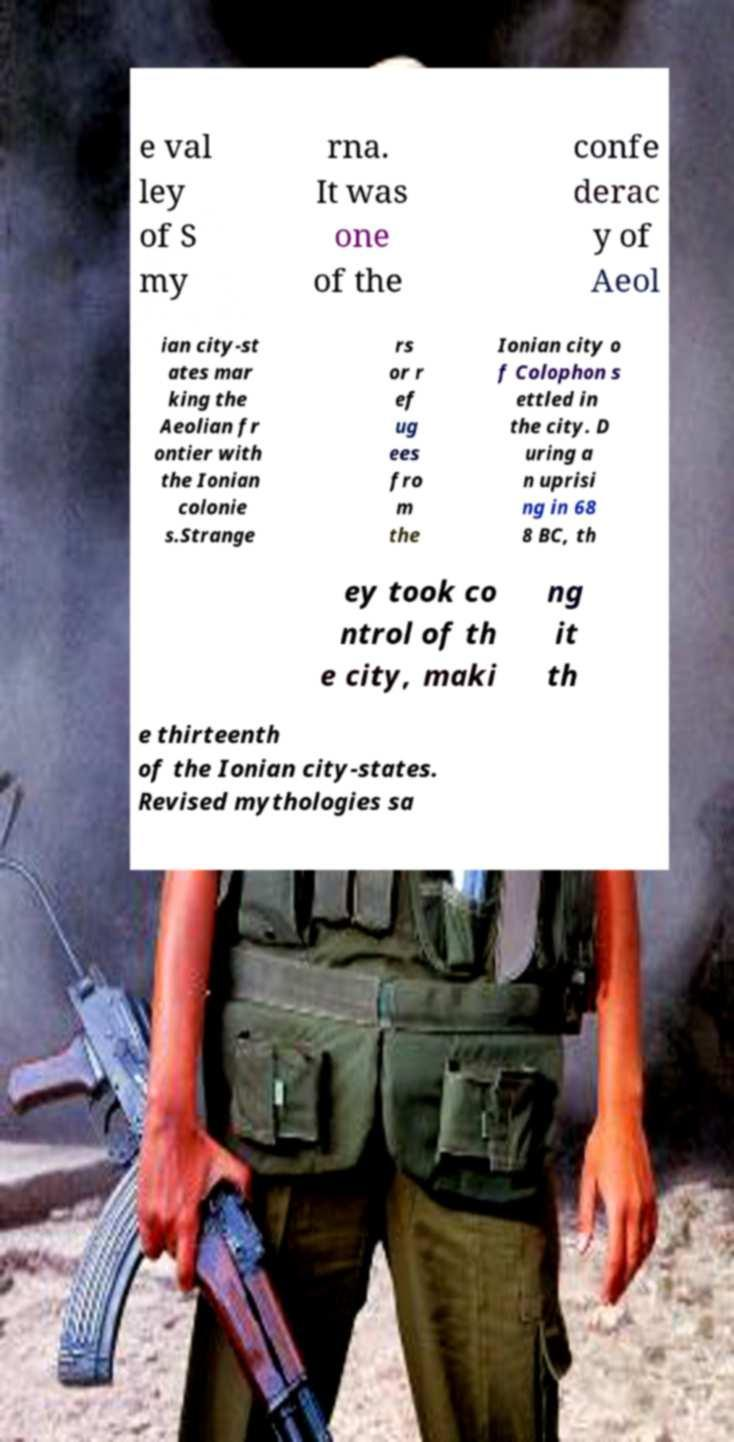Can you read and provide the text displayed in the image?This photo seems to have some interesting text. Can you extract and type it out for me? e val ley of S my rna. It was one of the confe derac y of Aeol ian city-st ates mar king the Aeolian fr ontier with the Ionian colonie s.Strange rs or r ef ug ees fro m the Ionian city o f Colophon s ettled in the city. D uring a n uprisi ng in 68 8 BC, th ey took co ntrol of th e city, maki ng it th e thirteenth of the Ionian city-states. Revised mythologies sa 